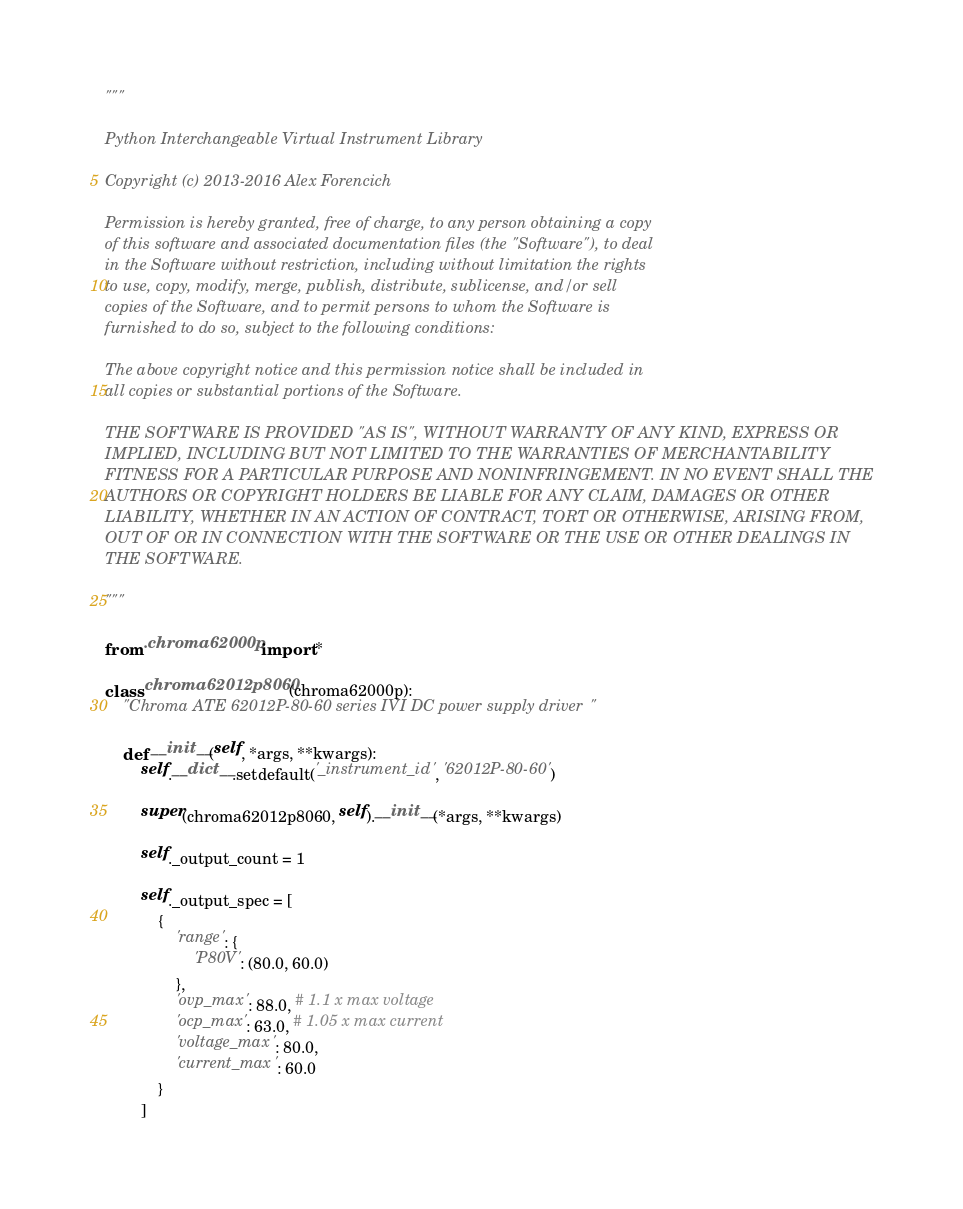Convert code to text. <code><loc_0><loc_0><loc_500><loc_500><_Python_>"""

Python Interchangeable Virtual Instrument Library

Copyright (c) 2013-2016 Alex Forencich

Permission is hereby granted, free of charge, to any person obtaining a copy
of this software and associated documentation files (the "Software"), to deal
in the Software without restriction, including without limitation the rights
to use, copy, modify, merge, publish, distribute, sublicense, and/or sell
copies of the Software, and to permit persons to whom the Software is
furnished to do so, subject to the following conditions:

The above copyright notice and this permission notice shall be included in
all copies or substantial portions of the Software.

THE SOFTWARE IS PROVIDED "AS IS", WITHOUT WARRANTY OF ANY KIND, EXPRESS OR
IMPLIED, INCLUDING BUT NOT LIMITED TO THE WARRANTIES OF MERCHANTABILITY
FITNESS FOR A PARTICULAR PURPOSE AND NONINFRINGEMENT. IN NO EVENT SHALL THE
AUTHORS OR COPYRIGHT HOLDERS BE LIABLE FOR ANY CLAIM, DAMAGES OR OTHER
LIABILITY, WHETHER IN AN ACTION OF CONTRACT, TORT OR OTHERWISE, ARISING FROM,
OUT OF OR IN CONNECTION WITH THE SOFTWARE OR THE USE OR OTHER DEALINGS IN
THE SOFTWARE.

"""

from .chroma62000p import *

class chroma62012p8060(chroma62000p):
    "Chroma ATE 62012P-80-60 series IVI DC power supply driver"
    
    def __init__(self, *args, **kwargs):
        self.__dict__.setdefault('_instrument_id', '62012P-80-60')
        
        super(chroma62012p8060, self).__init__(*args, **kwargs)
        
        self._output_count = 1
        
        self._output_spec = [
            {
                'range': {
                    'P80V': (80.0, 60.0)
                },
                'ovp_max': 88.0, # 1.1 x max voltage
                'ocp_max': 63.0, # 1.05 x max current
                'voltage_max': 80.0,
                'current_max': 60.0
            }
        ]
</code> 